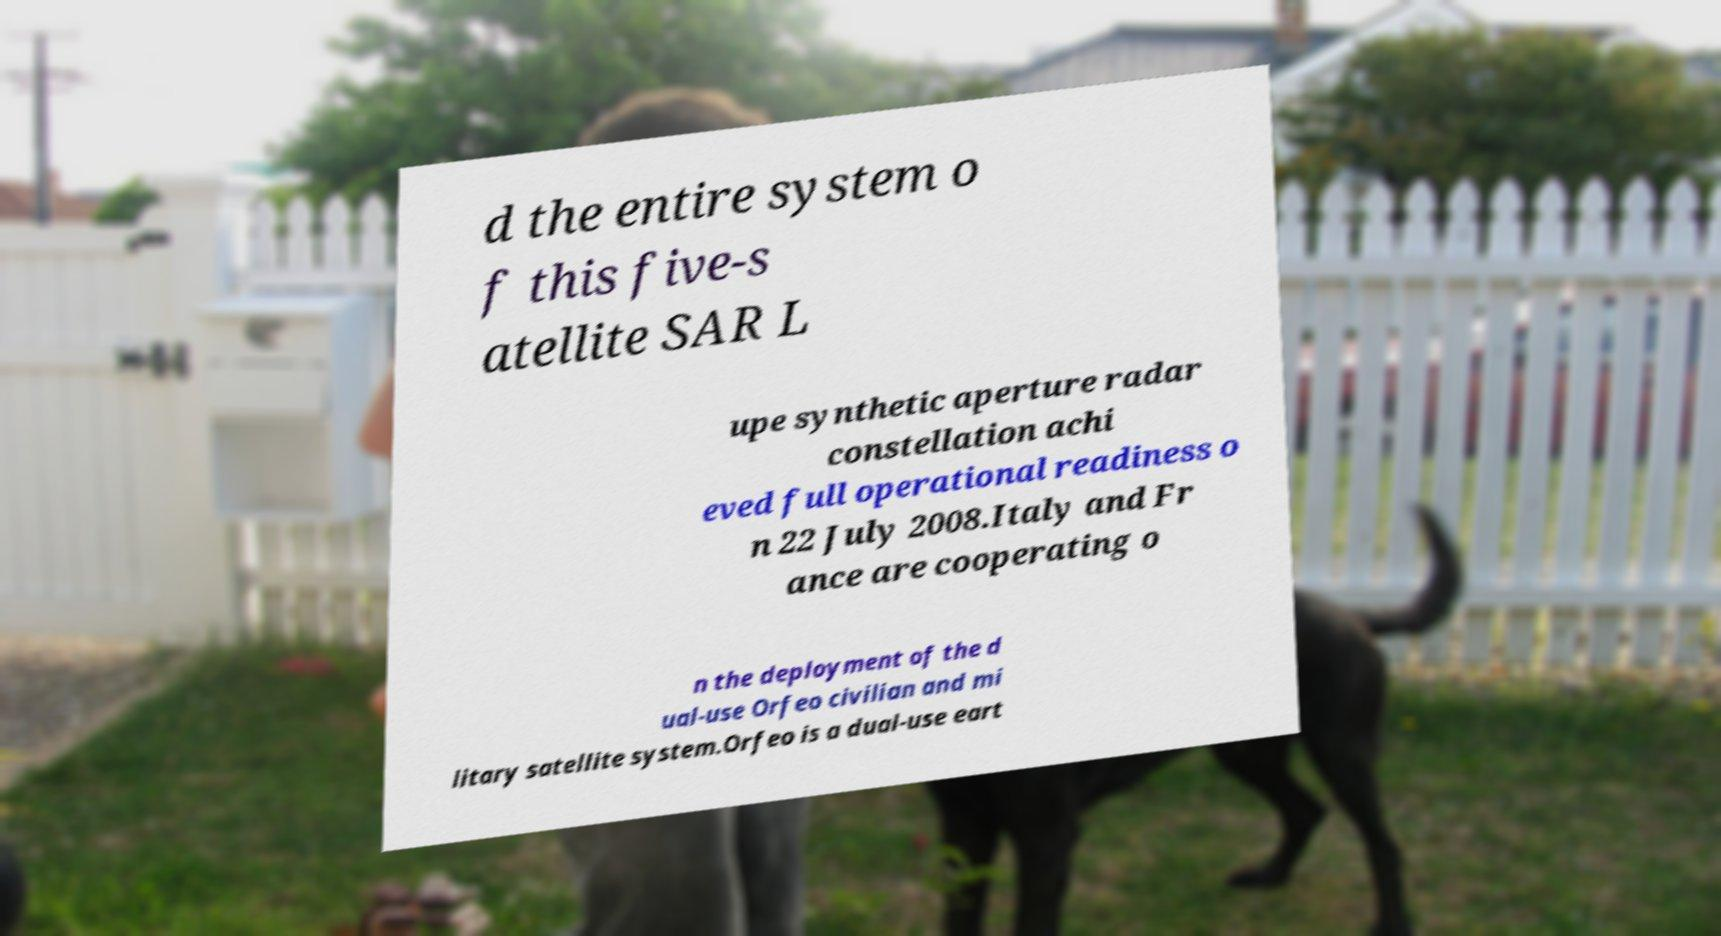There's text embedded in this image that I need extracted. Can you transcribe it verbatim? d the entire system o f this five-s atellite SAR L upe synthetic aperture radar constellation achi eved full operational readiness o n 22 July 2008.Italy and Fr ance are cooperating o n the deployment of the d ual-use Orfeo civilian and mi litary satellite system.Orfeo is a dual-use eart 